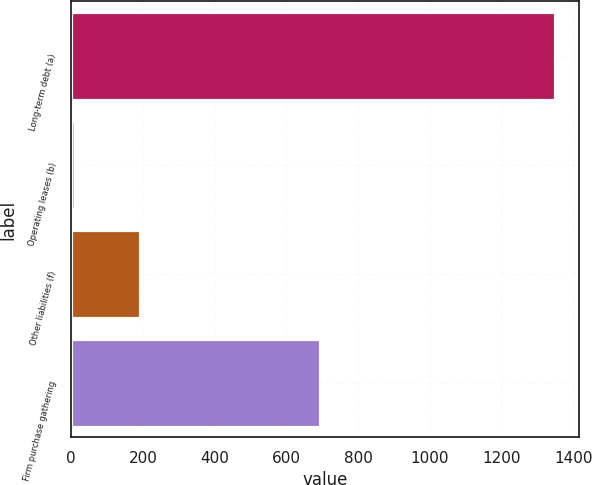Convert chart to OTSL. <chart><loc_0><loc_0><loc_500><loc_500><bar_chart><fcel>Long-term debt (a)<fcel>Operating leases (b)<fcel>Other liabilities (f)<fcel>Firm purchase gathering<nl><fcel>1350<fcel>11<fcel>193<fcel>694<nl></chart> 